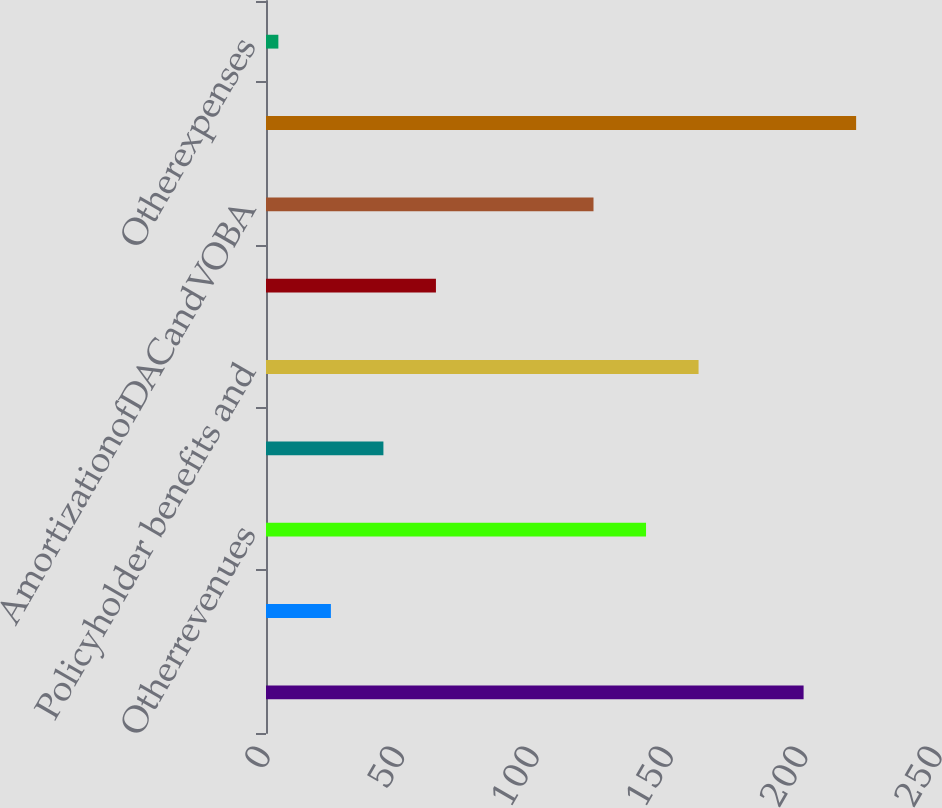Convert chart. <chart><loc_0><loc_0><loc_500><loc_500><bar_chart><ecel><fcel>Netinvestmentincome<fcel>Otherrevenues<fcel>Totaloperatingrevenues<fcel>Policyholder benefits and<fcel>CapitalizationofDAC<fcel>AmortizationofDACandVOBA<fcel>Interest expense<fcel>Otherexpenses<nl><fcel>200<fcel>24.14<fcel>141.38<fcel>43.68<fcel>160.92<fcel>63.22<fcel>121.84<fcel>219.54<fcel>4.6<nl></chart> 